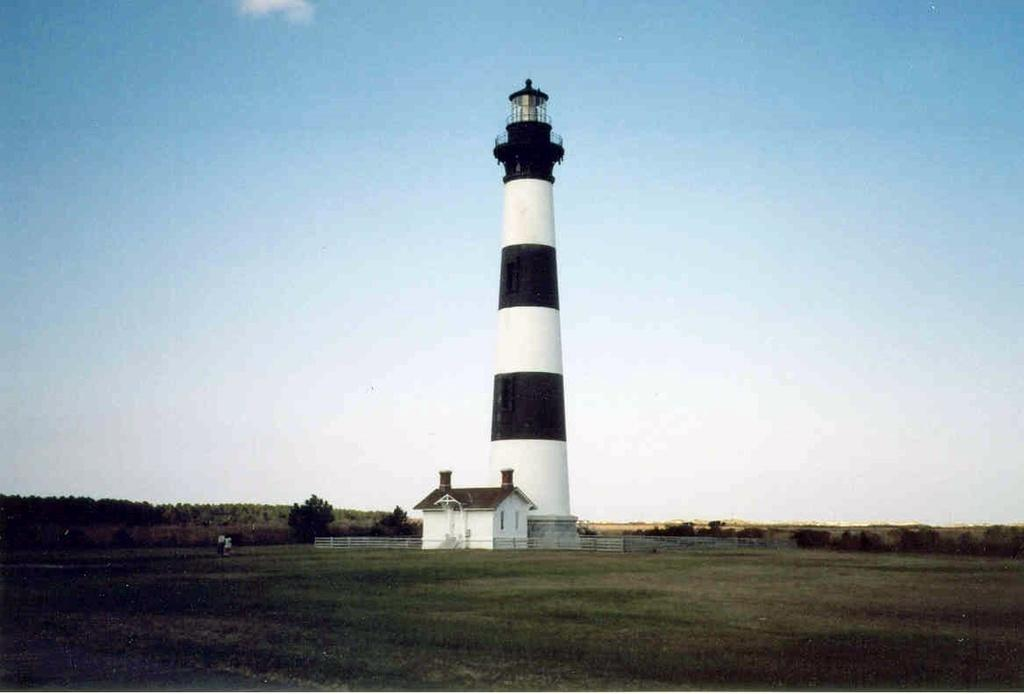What type of vegetation can be seen in the image? There is grass in the image. What structure is present in the image? There is a tower in the image. What type of building can be seen in the image? There is a shed in the image. What type of barrier is present in the image? There are fences in the image. What type of natural feature is present in the image? There are trees in the image. What is visible in the background of the image? The sky is visible in the background of the image. What type of eggnog is being served in the image? There is no eggnog present in the image. What type of tank is visible in the image? There is no tank present in the image. 